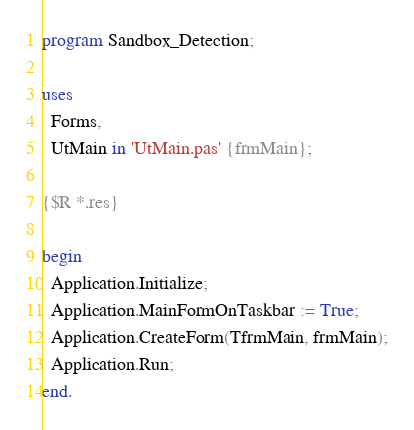Convert code to text. <code><loc_0><loc_0><loc_500><loc_500><_Pascal_>program Sandbox_Detection;

uses
  Forms,
  UtMain in 'UtMain.pas' {frmMain};

{$R *.res}

begin
  Application.Initialize;
  Application.MainFormOnTaskbar := True;
  Application.CreateForm(TfrmMain, frmMain);
  Application.Run;
end.
</code> 